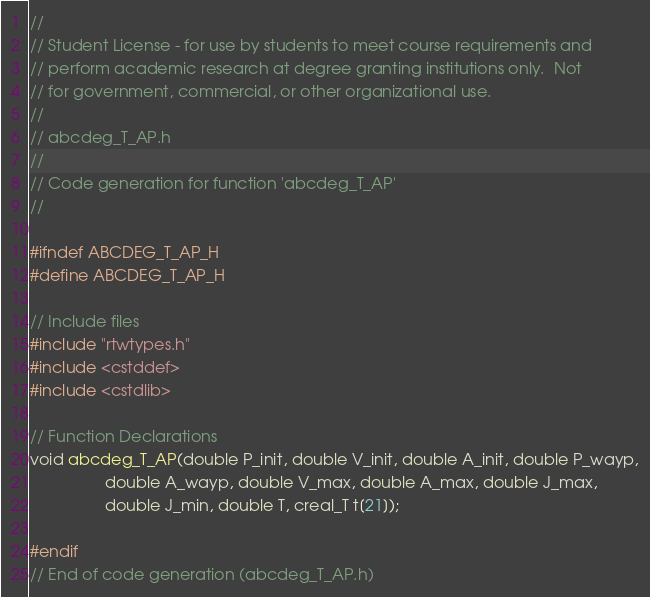<code> <loc_0><loc_0><loc_500><loc_500><_C_>//
// Student License - for use by students to meet course requirements and
// perform academic research at degree granting institutions only.  Not
// for government, commercial, or other organizational use.
//
// abcdeg_T_AP.h
//
// Code generation for function 'abcdeg_T_AP'
//

#ifndef ABCDEG_T_AP_H
#define ABCDEG_T_AP_H

// Include files
#include "rtwtypes.h"
#include <cstddef>
#include <cstdlib>

// Function Declarations
void abcdeg_T_AP(double P_init, double V_init, double A_init, double P_wayp,
                 double A_wayp, double V_max, double A_max, double J_max,
                 double J_min, double T, creal_T t[21]);

#endif
// End of code generation (abcdeg_T_AP.h)
</code> 